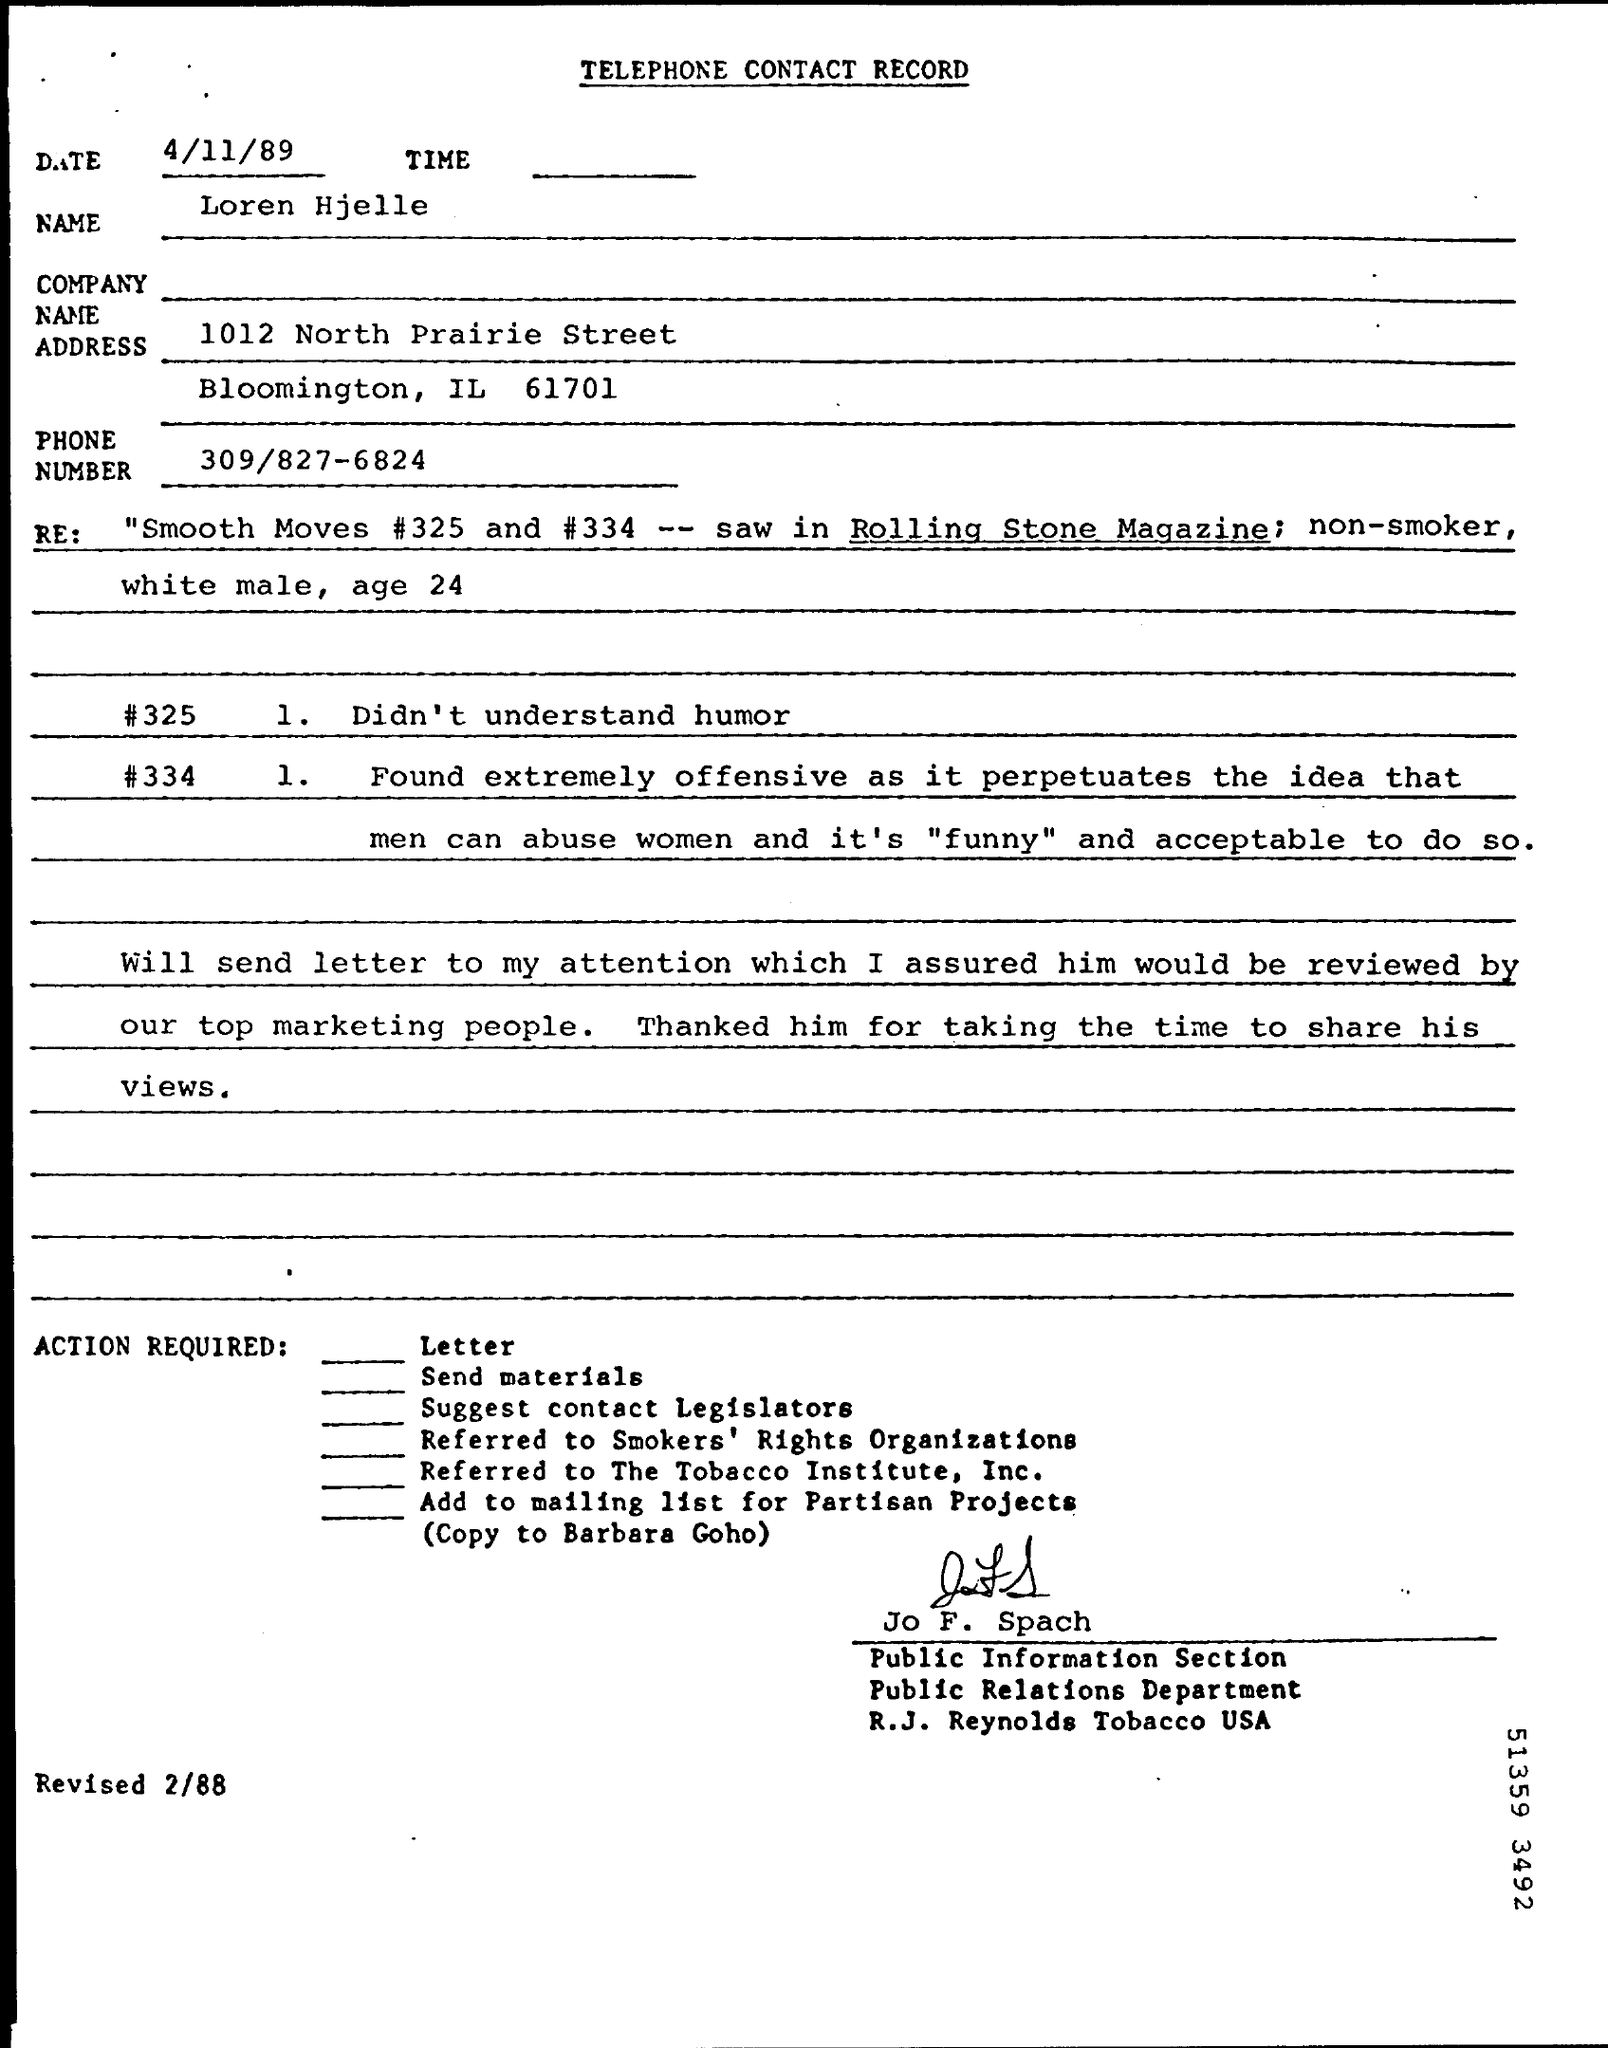What is the Title of the document?
Give a very brief answer. Telephone contact record. What is the Date?
Make the answer very short. 4/11/89. What is the Name?
Provide a succinct answer. Loren Hjelle. What is the Phone Number?
Make the answer very short. 309/827-6824. Who is this letter from?
Provide a succinct answer. Jo F. Spach. What is the date mentioned ?
Give a very brief answer. 4/11/89. What is the state and city name mentioned in the address
Offer a very short reply. Bloomington , IL. What is the name of the company mentioned ?
Ensure brevity in your answer.  R.J. Reynolds Tobacco USA. What is the name of the department mentioned ?
Provide a short and direct response. Public Relations Department. What is the phone number mentioned ?
Give a very brief answer. 309/827-6824. What is the age mentioned in the re:
Your answer should be very brief. 24. Jo F. Spach belongs to which department ?
Your answer should be very brief. Public Relations Department. 